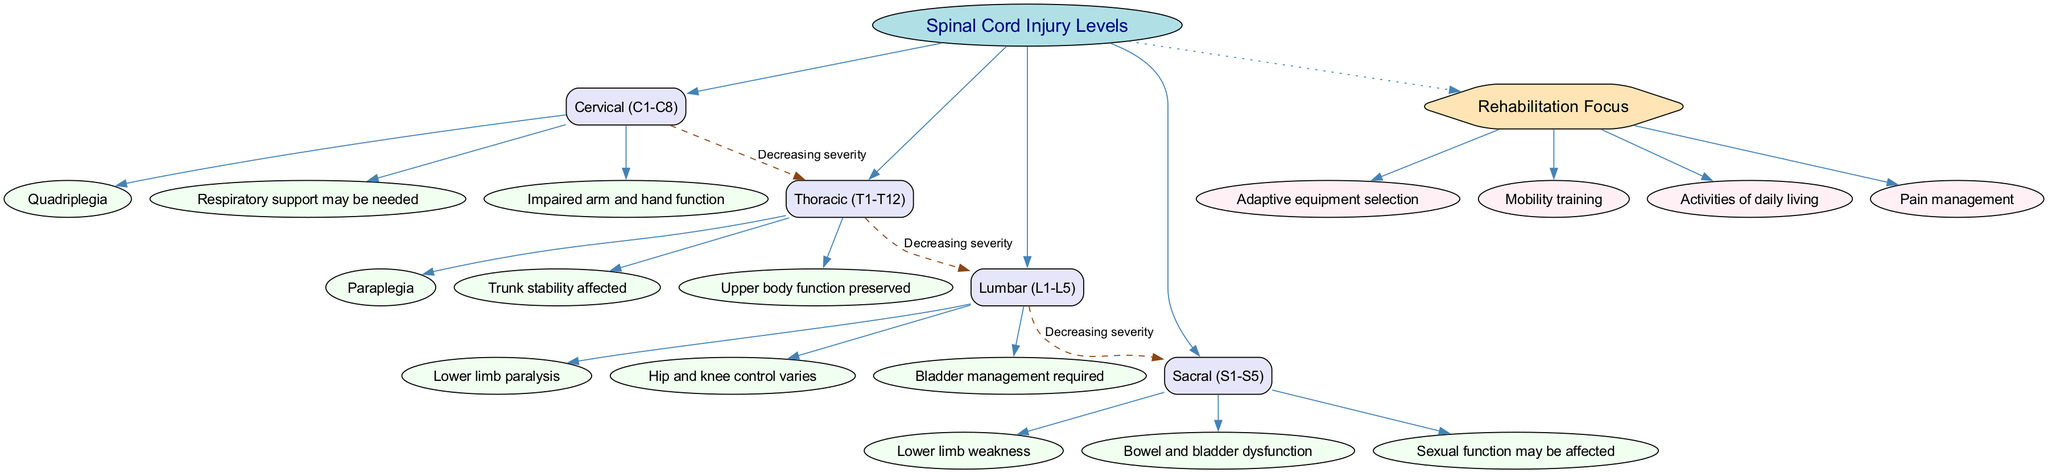What is the central topic of the diagram? The title of the diagram provides the central theme. It states "Spinal Cord Injury Levels" prominently in the center.
Answer: Spinal Cord Injury Levels How many main branches are present in the diagram? The diagram shows four main branches directly connected to the central topic. Counting them gives us a total of four.
Answer: 4 What type of paralysis is associated with cervical injuries? The sub-branches under the cervical main branch specify "Quadriplegia" as the type of paralysis associated with cervical injuries.
Answer: Quadriplegia What affects trunk stability according to the thoracic branch? The thoracic main branch has a sub-branch stating "Trunk stability affected," indicating this specific impact.
Answer: Trunk stability affected Which injury level requires bladder management? The lumbar branch includes a sub-branch that specifies "Bladder management required," which answers the question of what level necessitates this focus.
Answer: Lumbar (L1-L5) What is the connection label between the lumbar and sacral levels? The connections between injury levels are labeled with "Decreasing severity." This same label applies from lumbar to sacral.
Answer: Decreasing severity Which aspect of rehabilitation is concerned with everyday activities? One of the rehabilitation focus aspects is listed as "Activities of daily living," indicating that it addresses this area.
Answer: Activities of daily living What type of support may be needed for cervical injuries? The cervical main branch specifically lists "Respiratory support may be needed" as a consequence of spinal injuries at this level.
Answer: Respiratory support may be needed What condition might be affected at the sacral injury level? The sacral sub-branch mentions that "Sexual function may be affected," indicating potential issues arising from this injury level.
Answer: Sexual function may be affected 